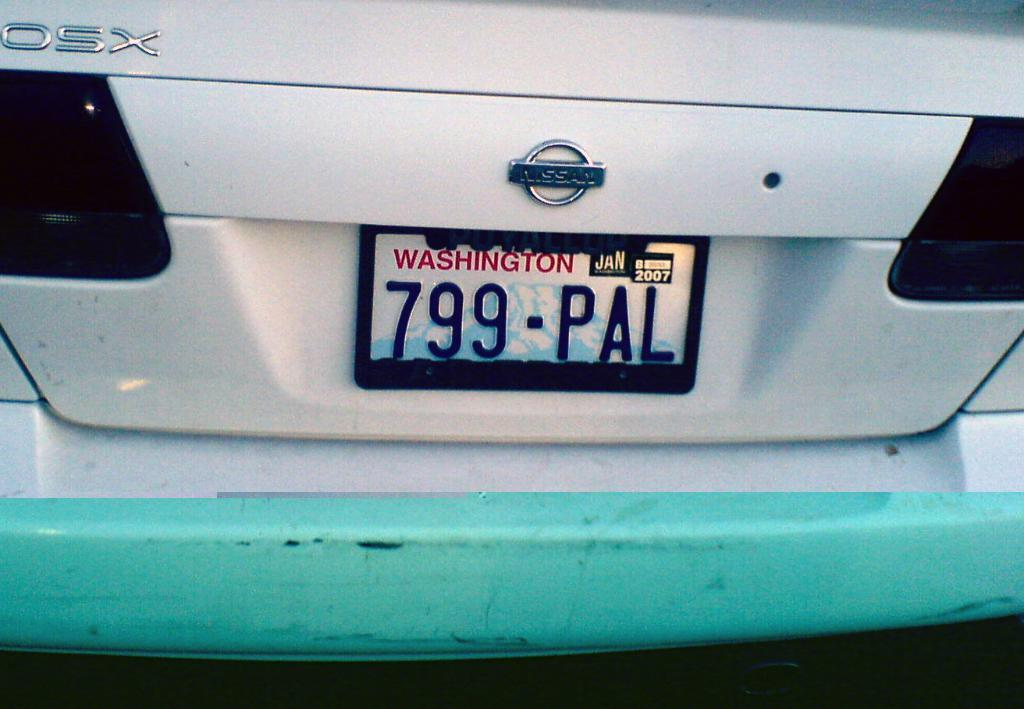<image>
Share a concise interpretation of the image provided. A white Nissan with a Washington tag that reads 799-PAL. 